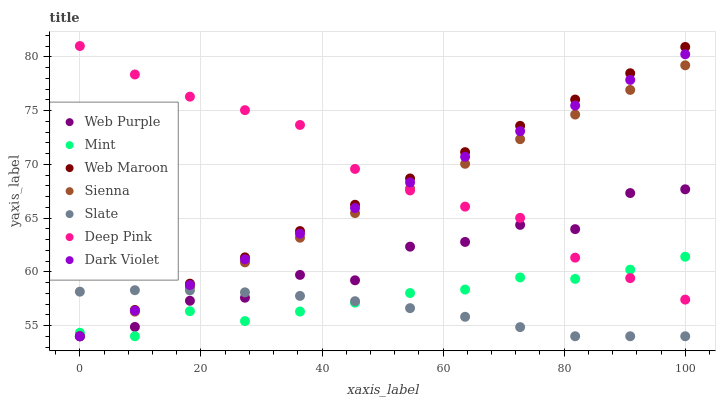Does Slate have the minimum area under the curve?
Answer yes or no. Yes. Does Deep Pink have the maximum area under the curve?
Answer yes or no. Yes. Does Web Maroon have the minimum area under the curve?
Answer yes or no. No. Does Web Maroon have the maximum area under the curve?
Answer yes or no. No. Is Dark Violet the smoothest?
Answer yes or no. Yes. Is Web Purple the roughest?
Answer yes or no. Yes. Is Slate the smoothest?
Answer yes or no. No. Is Slate the roughest?
Answer yes or no. No. Does Slate have the lowest value?
Answer yes or no. Yes. Does Deep Pink have the highest value?
Answer yes or no. Yes. Does Web Maroon have the highest value?
Answer yes or no. No. Is Slate less than Deep Pink?
Answer yes or no. Yes. Is Deep Pink greater than Slate?
Answer yes or no. Yes. Does Deep Pink intersect Web Maroon?
Answer yes or no. Yes. Is Deep Pink less than Web Maroon?
Answer yes or no. No. Is Deep Pink greater than Web Maroon?
Answer yes or no. No. Does Slate intersect Deep Pink?
Answer yes or no. No. 